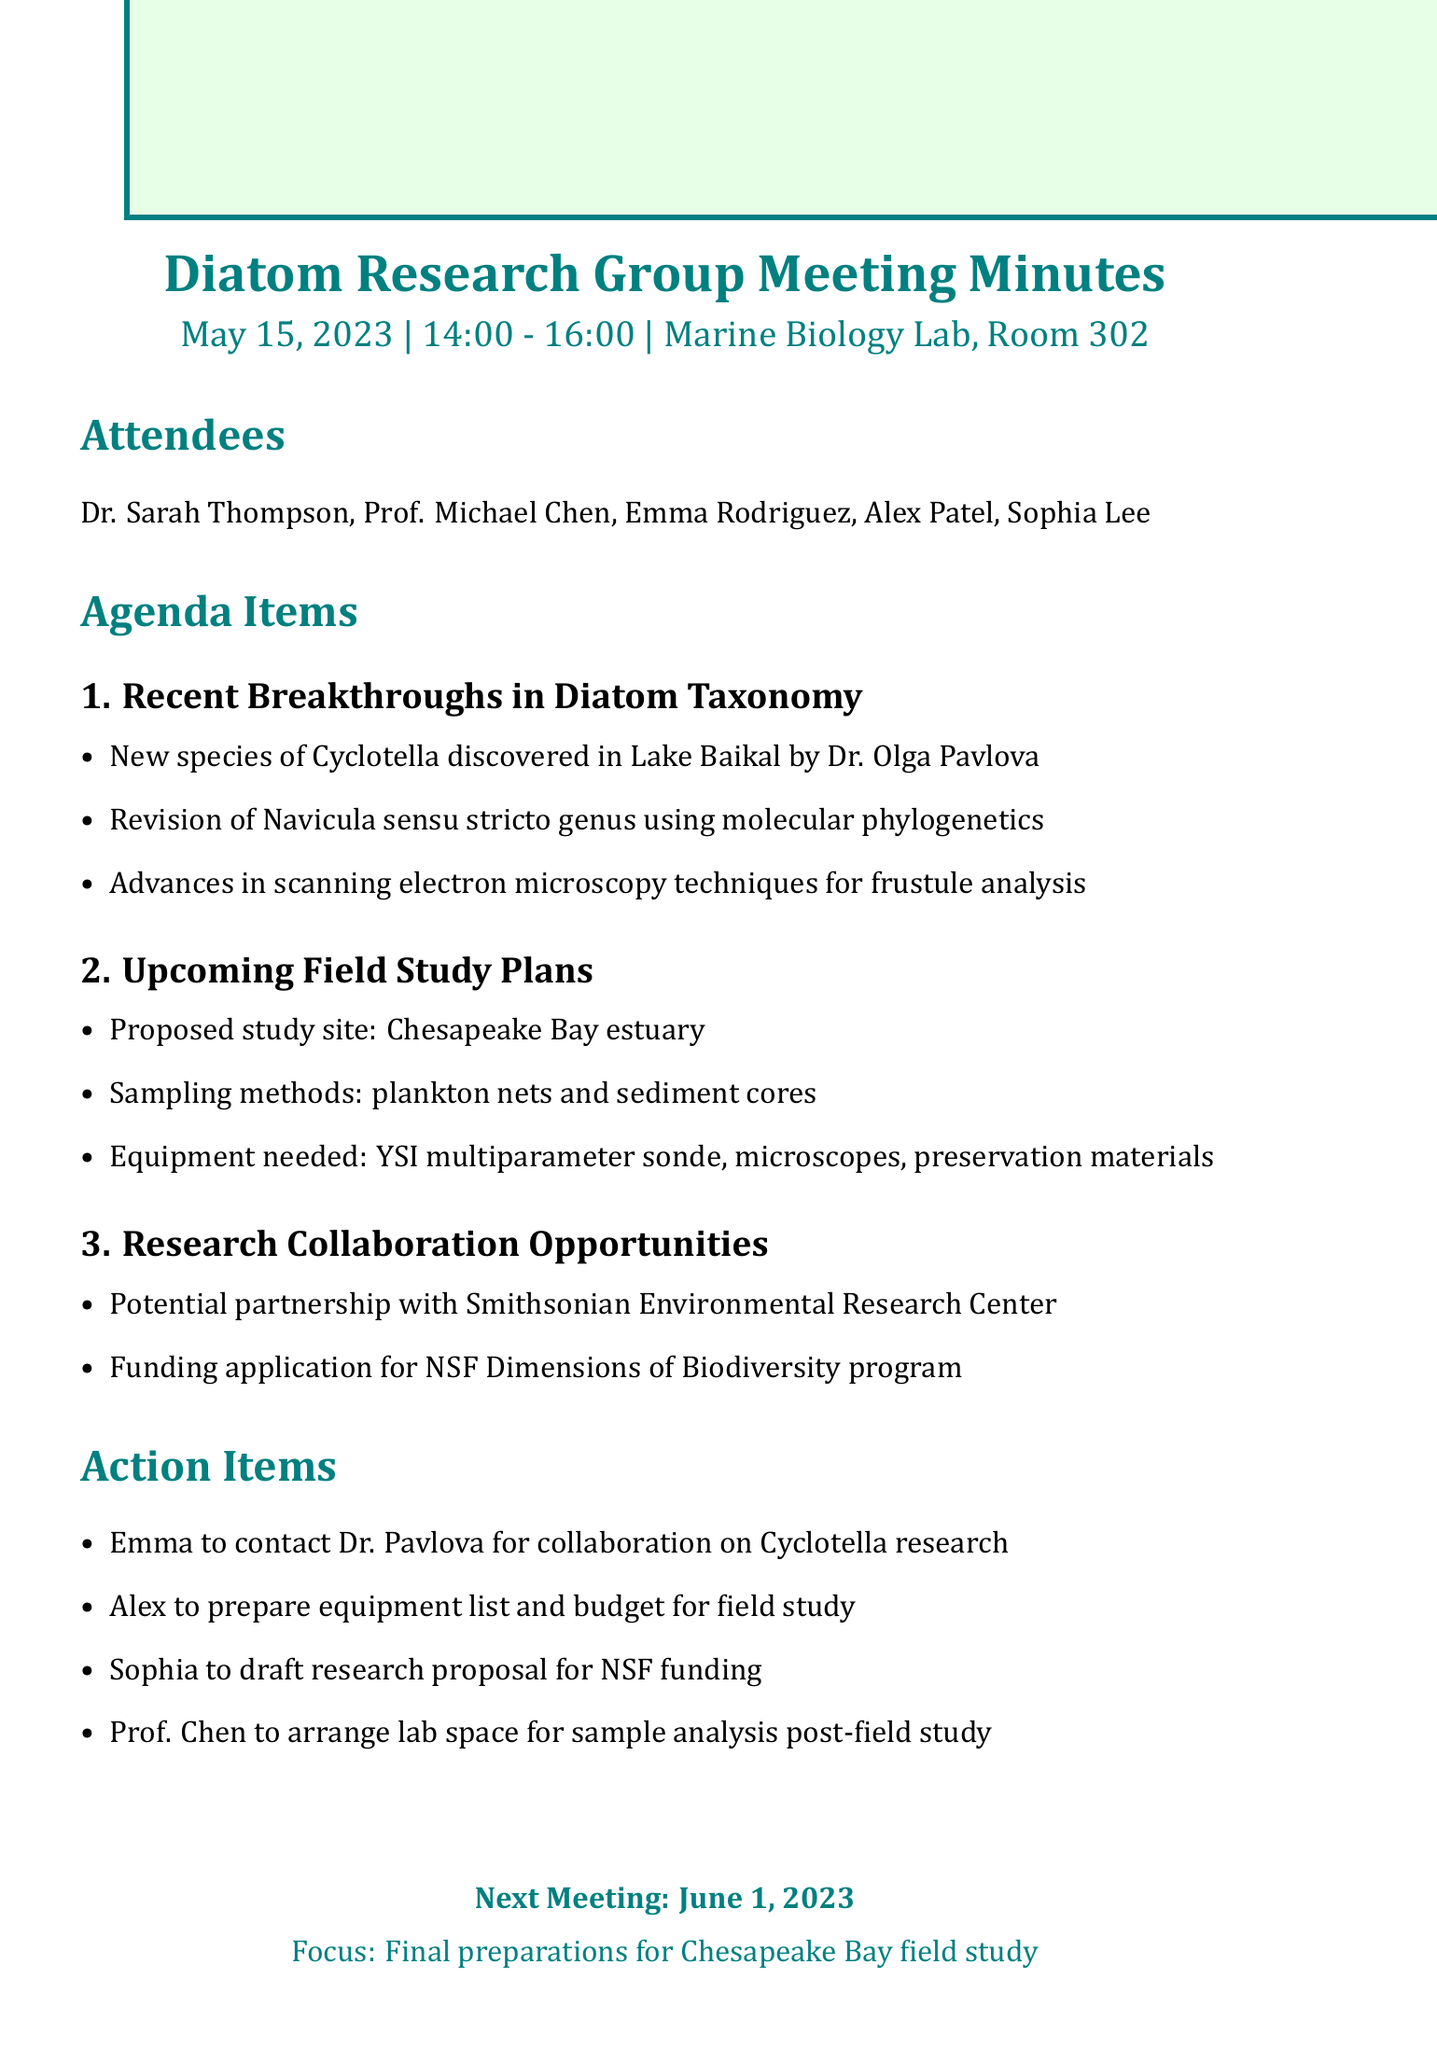What is the date of the meeting? The date of the meeting is specified in the document.
Answer: May 15, 2023 Who discovered a new species of Cyclotella? The document mentions the individual responsible for the discovery of the new Cyclotella species.
Answer: Dr. Olga Pavlova What is the proposed study site for the upcoming field study? The document outlines the location planned for the field study.
Answer: Chesapeake Bay estuary What sampling methods will be used in the field study? The document lists the methods planned for sampling during the study.
Answer: Plankton nets and sediment cores What is one potential partner for research collaboration? The document highlights a specific organization as a potential partnership opportunity.
Answer: Smithsonian Environmental Research Center Who is responsible for preparing the equipment list and budget? The document indicates who will handle equipment preparations for the field study.
Answer: Alex How many attendees were present at the meeting? The document lists the individuals who attended the meeting, allowing for a count.
Answer: Five What is the focus of the next meeting? The document specifies the main topic to be addressed in the subsequent meeting.
Answer: Final preparations for Chesapeake Bay field study 